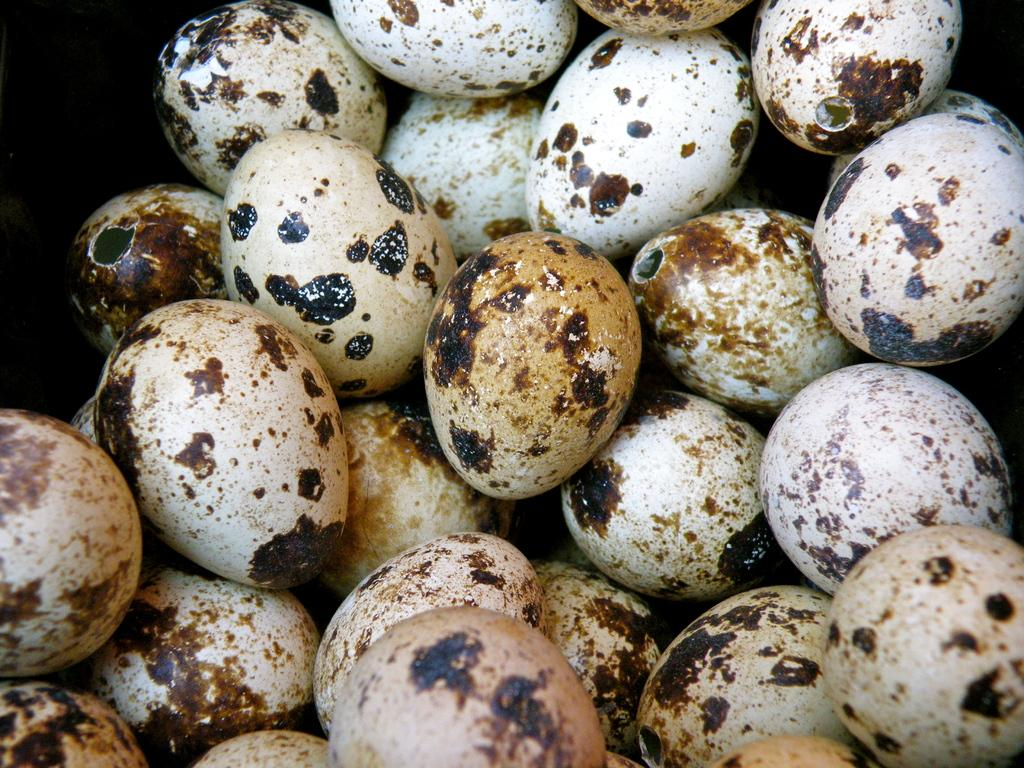What is the main subject of the image? The main subject of the image is eggs. Can you describe the location of the eggs in the image? The eggs are in the center of the image. How many brothers are depicted with the eggs in the image? There are no people, including brothers, present in the image; it only features eggs. 